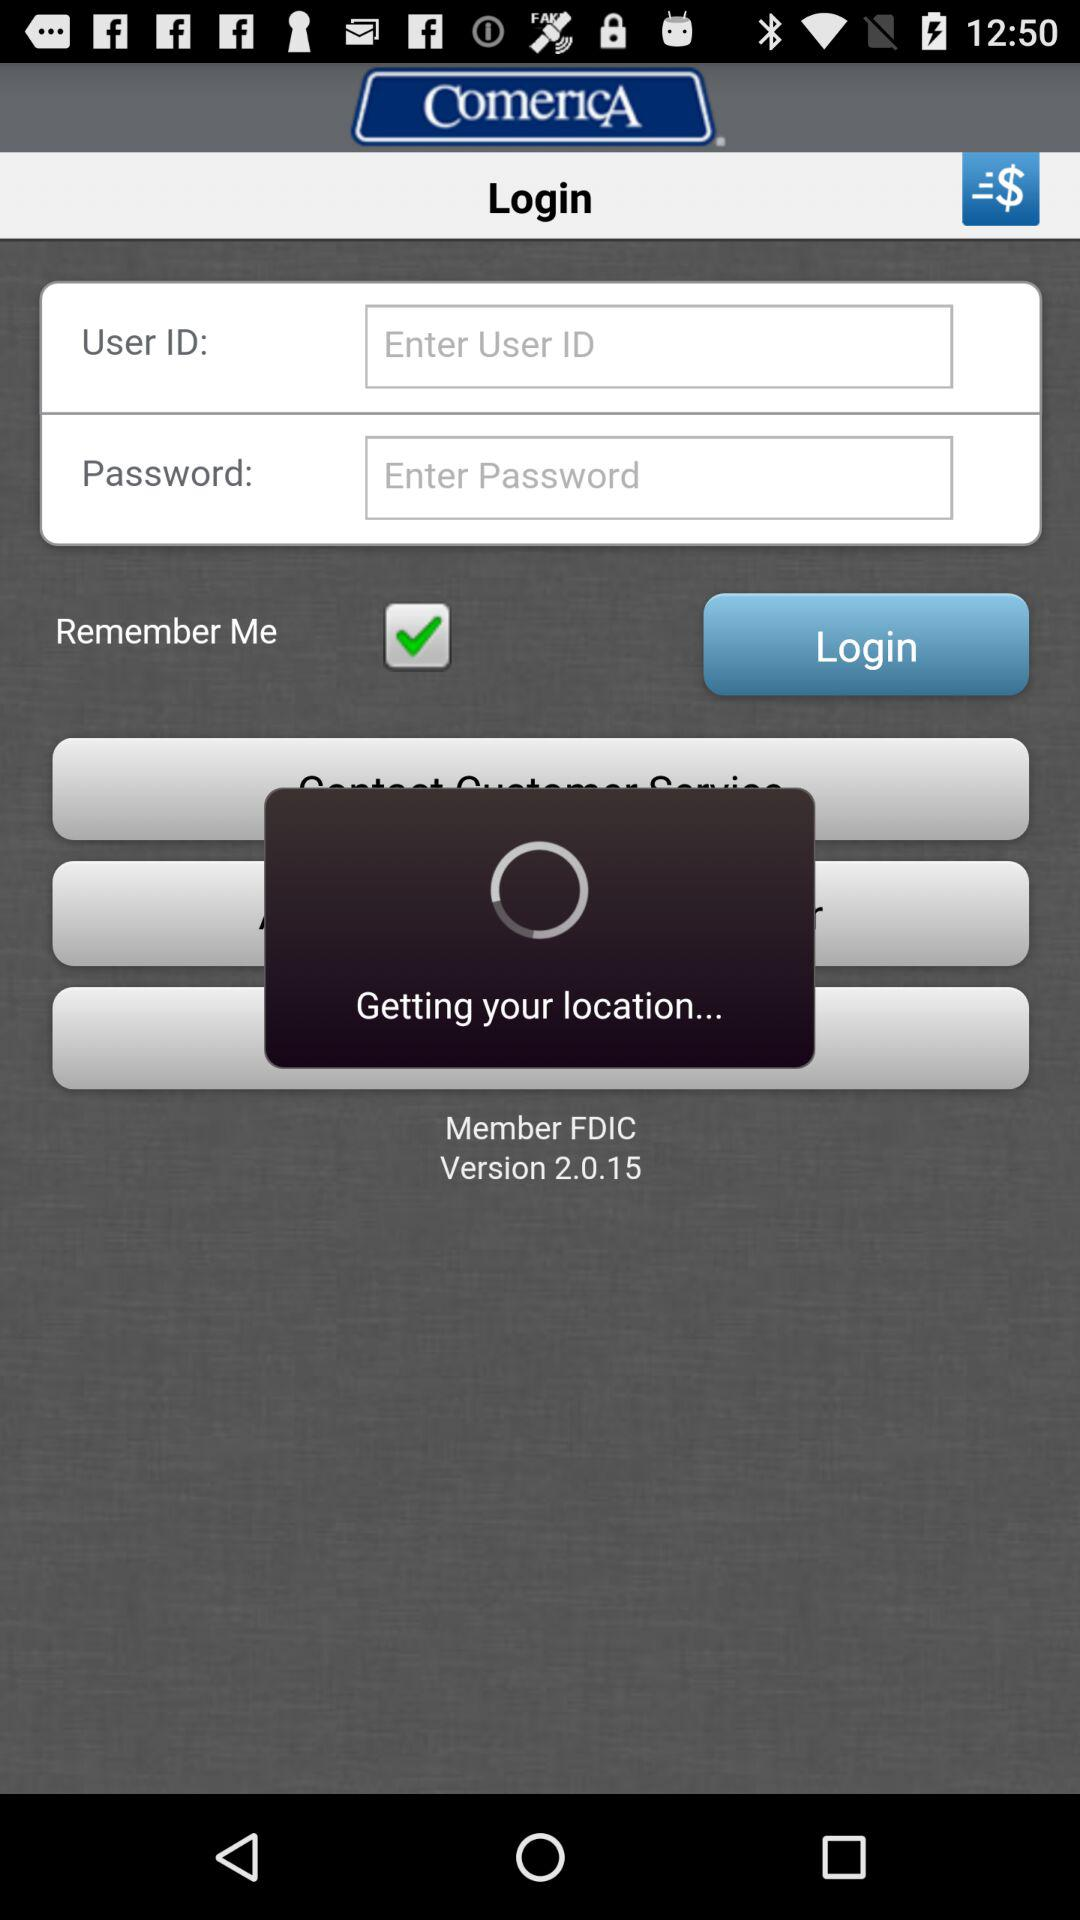Which option is selected? The selected option is "Favorites". 